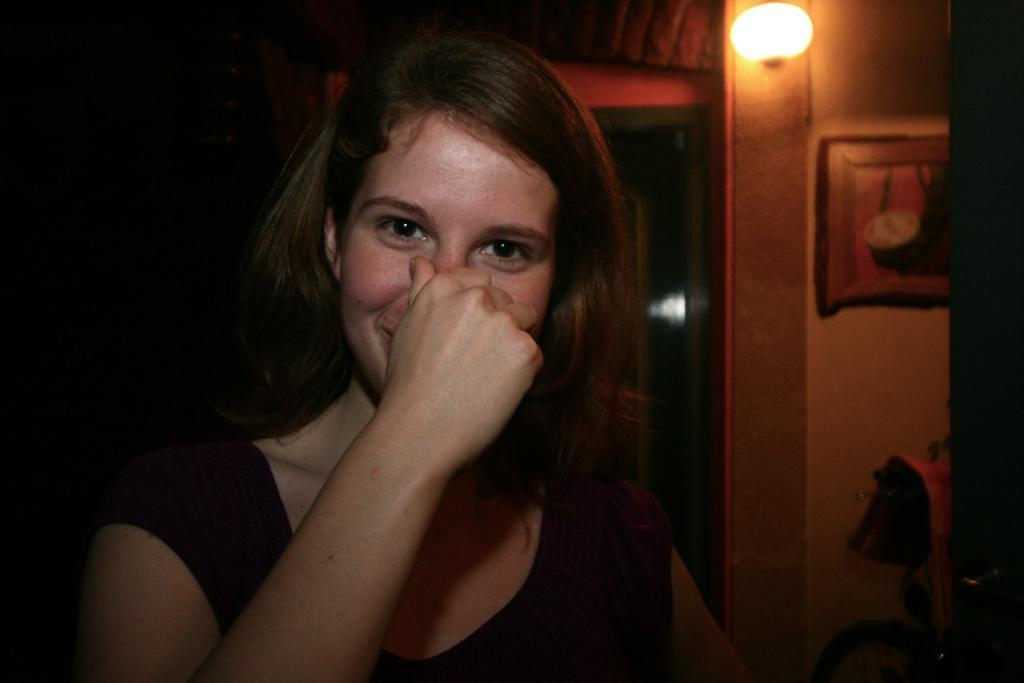Could you give a brief overview of what you see in this image? In this image, we can see a woman touching her nose with her hand. In the background, we can see the dark view, wall, light, photo frame and few objects. 